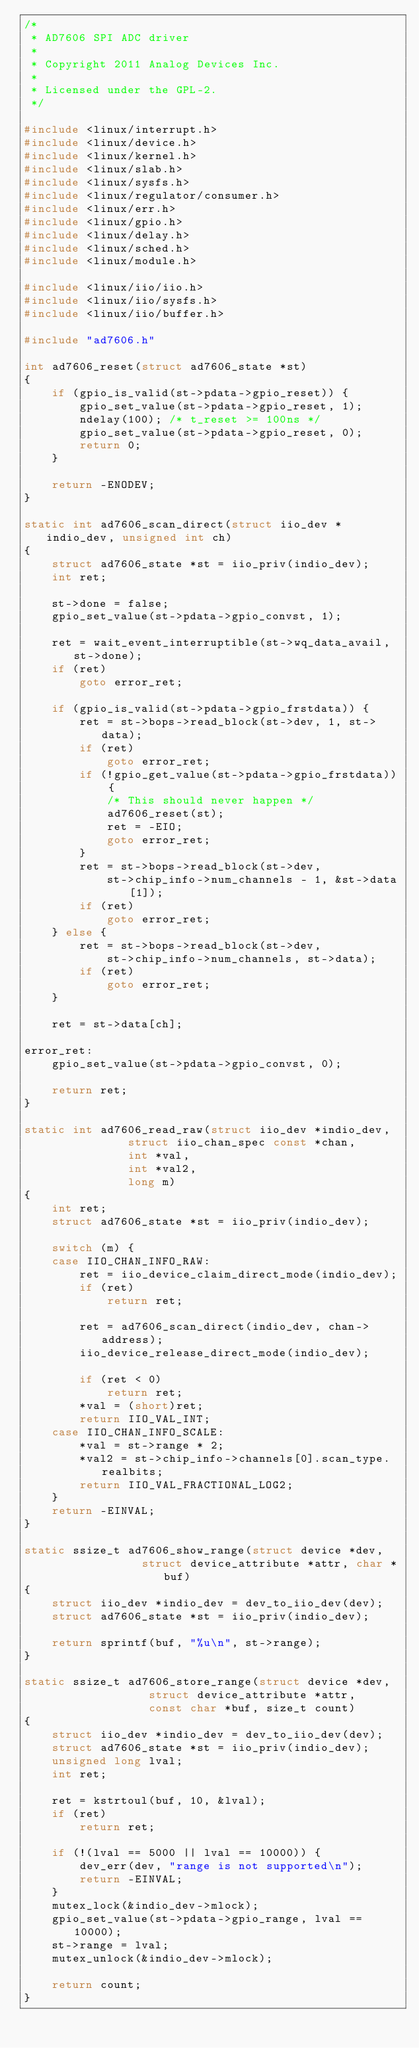Convert code to text. <code><loc_0><loc_0><loc_500><loc_500><_C_>/*
 * AD7606 SPI ADC driver
 *
 * Copyright 2011 Analog Devices Inc.
 *
 * Licensed under the GPL-2.
 */

#include <linux/interrupt.h>
#include <linux/device.h>
#include <linux/kernel.h>
#include <linux/slab.h>
#include <linux/sysfs.h>
#include <linux/regulator/consumer.h>
#include <linux/err.h>
#include <linux/gpio.h>
#include <linux/delay.h>
#include <linux/sched.h>
#include <linux/module.h>

#include <linux/iio/iio.h>
#include <linux/iio/sysfs.h>
#include <linux/iio/buffer.h>

#include "ad7606.h"

int ad7606_reset(struct ad7606_state *st)
{
	if (gpio_is_valid(st->pdata->gpio_reset)) {
		gpio_set_value(st->pdata->gpio_reset, 1);
		ndelay(100); /* t_reset >= 100ns */
		gpio_set_value(st->pdata->gpio_reset, 0);
		return 0;
	}

	return -ENODEV;
}

static int ad7606_scan_direct(struct iio_dev *indio_dev, unsigned int ch)
{
	struct ad7606_state *st = iio_priv(indio_dev);
	int ret;

	st->done = false;
	gpio_set_value(st->pdata->gpio_convst, 1);

	ret = wait_event_interruptible(st->wq_data_avail, st->done);
	if (ret)
		goto error_ret;

	if (gpio_is_valid(st->pdata->gpio_frstdata)) {
		ret = st->bops->read_block(st->dev, 1, st->data);
		if (ret)
			goto error_ret;
		if (!gpio_get_value(st->pdata->gpio_frstdata)) {
			/* This should never happen */
			ad7606_reset(st);
			ret = -EIO;
			goto error_ret;
		}
		ret = st->bops->read_block(st->dev,
			st->chip_info->num_channels - 1, &st->data[1]);
		if (ret)
			goto error_ret;
	} else {
		ret = st->bops->read_block(st->dev,
			st->chip_info->num_channels, st->data);
		if (ret)
			goto error_ret;
	}

	ret = st->data[ch];

error_ret:
	gpio_set_value(st->pdata->gpio_convst, 0);

	return ret;
}

static int ad7606_read_raw(struct iio_dev *indio_dev,
			   struct iio_chan_spec const *chan,
			   int *val,
			   int *val2,
			   long m)
{
	int ret;
	struct ad7606_state *st = iio_priv(indio_dev);

	switch (m) {
	case IIO_CHAN_INFO_RAW:
		ret = iio_device_claim_direct_mode(indio_dev);
		if (ret)
			return ret;

		ret = ad7606_scan_direct(indio_dev, chan->address);
		iio_device_release_direct_mode(indio_dev);

		if (ret < 0)
			return ret;
		*val = (short)ret;
		return IIO_VAL_INT;
	case IIO_CHAN_INFO_SCALE:
		*val = st->range * 2;
		*val2 = st->chip_info->channels[0].scan_type.realbits;
		return IIO_VAL_FRACTIONAL_LOG2;
	}
	return -EINVAL;
}

static ssize_t ad7606_show_range(struct device *dev,
				 struct device_attribute *attr, char *buf)
{
	struct iio_dev *indio_dev = dev_to_iio_dev(dev);
	struct ad7606_state *st = iio_priv(indio_dev);

	return sprintf(buf, "%u\n", st->range);
}

static ssize_t ad7606_store_range(struct device *dev,
				  struct device_attribute *attr,
				  const char *buf, size_t count)
{
	struct iio_dev *indio_dev = dev_to_iio_dev(dev);
	struct ad7606_state *st = iio_priv(indio_dev);
	unsigned long lval;
	int ret;

	ret = kstrtoul(buf, 10, &lval);
	if (ret)
		return ret;

	if (!(lval == 5000 || lval == 10000)) {
		dev_err(dev, "range is not supported\n");
		return -EINVAL;
	}
	mutex_lock(&indio_dev->mlock);
	gpio_set_value(st->pdata->gpio_range, lval == 10000);
	st->range = lval;
	mutex_unlock(&indio_dev->mlock);

	return count;
}
</code> 